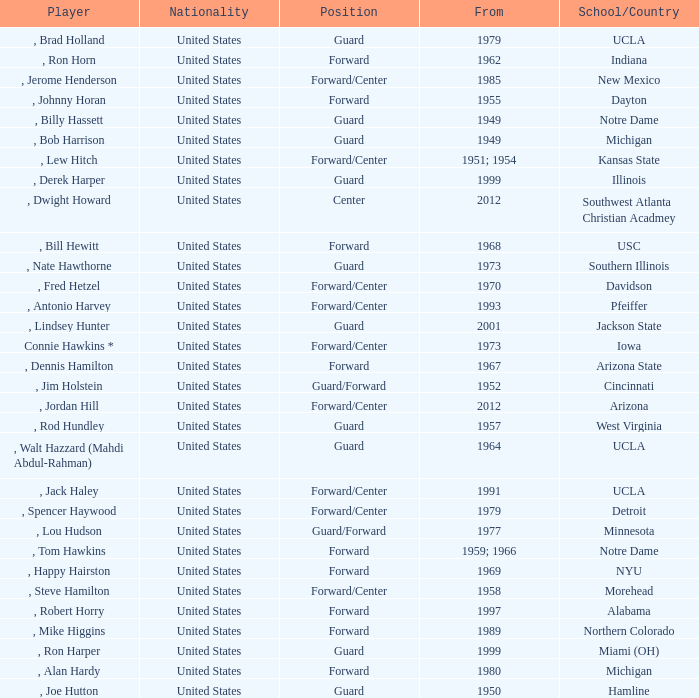Could you parse the entire table as a dict? {'header': ['Player', 'Nationality', 'Position', 'From', 'School/Country'], 'rows': [[', Brad Holland', 'United States', 'Guard', '1979', 'UCLA'], [', Ron Horn', 'United States', 'Forward', '1962', 'Indiana'], [', Jerome Henderson', 'United States', 'Forward/Center', '1985', 'New Mexico'], [', Johnny Horan', 'United States', 'Forward', '1955', 'Dayton'], [', Billy Hassett', 'United States', 'Guard', '1949', 'Notre Dame'], [', Bob Harrison', 'United States', 'Guard', '1949', 'Michigan'], [', Lew Hitch', 'United States', 'Forward/Center', '1951; 1954', 'Kansas State'], [', Derek Harper', 'United States', 'Guard', '1999', 'Illinois'], [', Dwight Howard', 'United States', 'Center', '2012', 'Southwest Atlanta Christian Acadmey'], [', Bill Hewitt', 'United States', 'Forward', '1968', 'USC'], [', Nate Hawthorne', 'United States', 'Guard', '1973', 'Southern Illinois'], [', Fred Hetzel', 'United States', 'Forward/Center', '1970', 'Davidson'], [', Antonio Harvey', 'United States', 'Forward/Center', '1993', 'Pfeiffer'], [', Lindsey Hunter', 'United States', 'Guard', '2001', 'Jackson State'], ['Connie Hawkins *', 'United States', 'Forward/Center', '1973', 'Iowa'], [', Dennis Hamilton', 'United States', 'Forward', '1967', 'Arizona State'], [', Jim Holstein', 'United States', 'Guard/Forward', '1952', 'Cincinnati'], [', Jordan Hill', 'United States', 'Forward/Center', '2012', 'Arizona'], [', Rod Hundley', 'United States', 'Guard', '1957', 'West Virginia'], [', Walt Hazzard (Mahdi Abdul-Rahman)', 'United States', 'Guard', '1964', 'UCLA'], [', Jack Haley', 'United States', 'Forward/Center', '1991', 'UCLA'], [', Spencer Haywood', 'United States', 'Forward/Center', '1979', 'Detroit'], [', Lou Hudson', 'United States', 'Guard/Forward', '1977', 'Minnesota'], [', Tom Hawkins', 'United States', 'Forward', '1959; 1966', 'Notre Dame'], [', Happy Hairston', 'United States', 'Forward', '1969', 'NYU'], [', Steve Hamilton', 'United States', 'Forward/Center', '1958', 'Morehead'], [', Robert Horry', 'United States', 'Forward', '1997', 'Alabama'], [', Mike Higgins', 'United States', 'Forward', '1989', 'Northern Colorado'], [', Ron Harper', 'United States', 'Guard', '1999', 'Miami (OH)'], [', Alan Hardy', 'United States', 'Forward', '1980', 'Michigan'], [', Joe Hutton', 'United States', 'Guard', '1950', 'Hamline']]} What position was for Arizona State? Forward. 